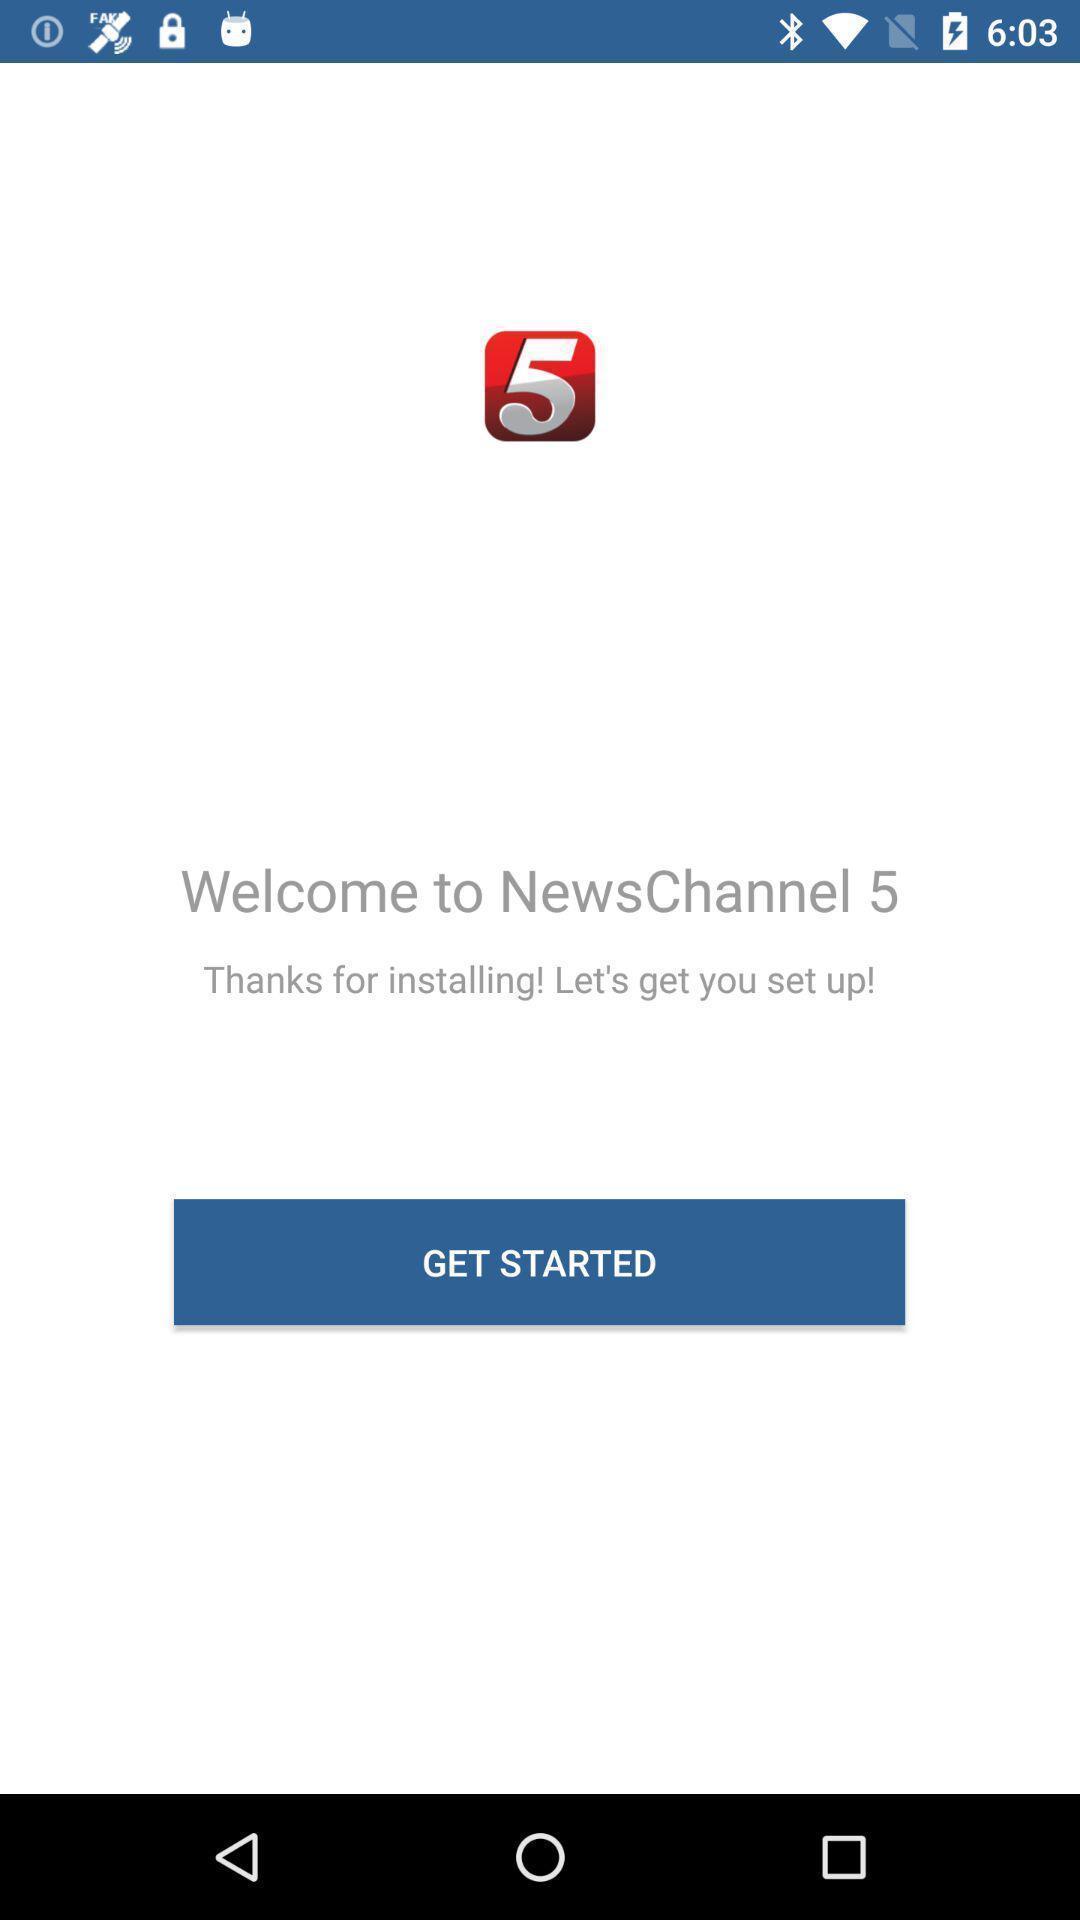Summarize the information in this screenshot. Welcoming page a news channel app. 